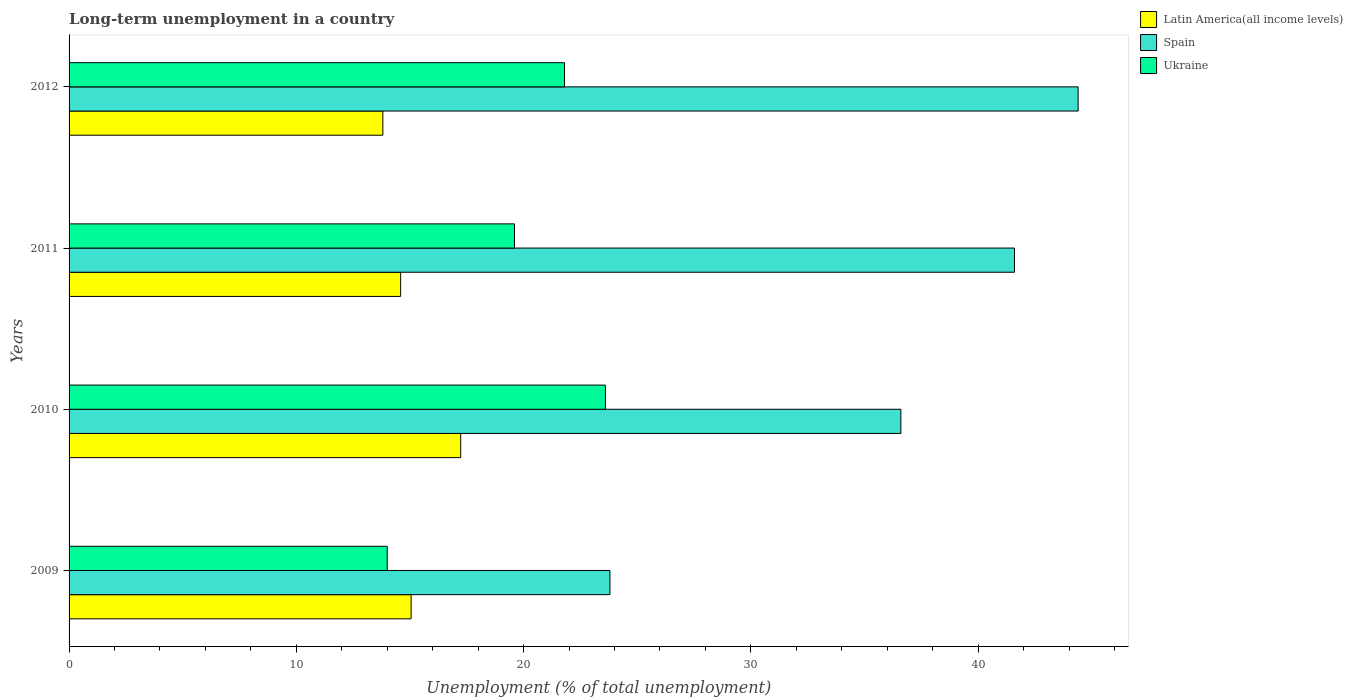How many different coloured bars are there?
Keep it short and to the point. 3. How many groups of bars are there?
Give a very brief answer. 4. Are the number of bars per tick equal to the number of legend labels?
Provide a succinct answer. Yes. Are the number of bars on each tick of the Y-axis equal?
Ensure brevity in your answer.  Yes. How many bars are there on the 3rd tick from the bottom?
Offer a very short reply. 3. What is the label of the 4th group of bars from the top?
Give a very brief answer. 2009. In how many cases, is the number of bars for a given year not equal to the number of legend labels?
Your response must be concise. 0. What is the percentage of long-term unemployed population in Ukraine in 2010?
Offer a very short reply. 23.6. Across all years, what is the maximum percentage of long-term unemployed population in Spain?
Ensure brevity in your answer.  44.4. Across all years, what is the minimum percentage of long-term unemployed population in Ukraine?
Provide a succinct answer. 14. In which year was the percentage of long-term unemployed population in Spain maximum?
Ensure brevity in your answer.  2012. What is the total percentage of long-term unemployed population in Latin America(all income levels) in the graph?
Offer a very short reply. 60.68. What is the difference between the percentage of long-term unemployed population in Latin America(all income levels) in 2009 and that in 2010?
Your response must be concise. -2.18. What is the difference between the percentage of long-term unemployed population in Ukraine in 2009 and the percentage of long-term unemployed population in Spain in 2012?
Provide a short and direct response. -30.4. What is the average percentage of long-term unemployed population in Latin America(all income levels) per year?
Provide a short and direct response. 15.17. In the year 2010, what is the difference between the percentage of long-term unemployed population in Ukraine and percentage of long-term unemployed population in Latin America(all income levels)?
Offer a very short reply. 6.37. What is the ratio of the percentage of long-term unemployed population in Ukraine in 2009 to that in 2010?
Offer a very short reply. 0.59. Is the percentage of long-term unemployed population in Latin America(all income levels) in 2009 less than that in 2012?
Provide a short and direct response. No. Is the difference between the percentage of long-term unemployed population in Ukraine in 2009 and 2010 greater than the difference between the percentage of long-term unemployed population in Latin America(all income levels) in 2009 and 2010?
Your answer should be very brief. No. What is the difference between the highest and the second highest percentage of long-term unemployed population in Spain?
Your response must be concise. 2.8. What is the difference between the highest and the lowest percentage of long-term unemployed population in Ukraine?
Your answer should be compact. 9.6. In how many years, is the percentage of long-term unemployed population in Ukraine greater than the average percentage of long-term unemployed population in Ukraine taken over all years?
Ensure brevity in your answer.  2. What does the 3rd bar from the bottom in 2009 represents?
Your response must be concise. Ukraine. Are all the bars in the graph horizontal?
Provide a succinct answer. Yes. How are the legend labels stacked?
Your response must be concise. Vertical. What is the title of the graph?
Make the answer very short. Long-term unemployment in a country. Does "Samoa" appear as one of the legend labels in the graph?
Provide a succinct answer. No. What is the label or title of the X-axis?
Keep it short and to the point. Unemployment (% of total unemployment). What is the label or title of the Y-axis?
Provide a succinct answer. Years. What is the Unemployment (% of total unemployment) in Latin America(all income levels) in 2009?
Offer a terse response. 15.05. What is the Unemployment (% of total unemployment) of Spain in 2009?
Provide a short and direct response. 23.8. What is the Unemployment (% of total unemployment) in Latin America(all income levels) in 2010?
Offer a terse response. 17.23. What is the Unemployment (% of total unemployment) in Spain in 2010?
Offer a very short reply. 36.6. What is the Unemployment (% of total unemployment) in Ukraine in 2010?
Give a very brief answer. 23.6. What is the Unemployment (% of total unemployment) in Latin America(all income levels) in 2011?
Give a very brief answer. 14.59. What is the Unemployment (% of total unemployment) of Spain in 2011?
Your response must be concise. 41.6. What is the Unemployment (% of total unemployment) of Ukraine in 2011?
Provide a short and direct response. 19.6. What is the Unemployment (% of total unemployment) of Latin America(all income levels) in 2012?
Ensure brevity in your answer.  13.81. What is the Unemployment (% of total unemployment) in Spain in 2012?
Offer a very short reply. 44.4. What is the Unemployment (% of total unemployment) in Ukraine in 2012?
Your answer should be compact. 21.8. Across all years, what is the maximum Unemployment (% of total unemployment) in Latin America(all income levels)?
Your answer should be very brief. 17.23. Across all years, what is the maximum Unemployment (% of total unemployment) of Spain?
Ensure brevity in your answer.  44.4. Across all years, what is the maximum Unemployment (% of total unemployment) in Ukraine?
Your response must be concise. 23.6. Across all years, what is the minimum Unemployment (% of total unemployment) in Latin America(all income levels)?
Your answer should be compact. 13.81. Across all years, what is the minimum Unemployment (% of total unemployment) in Spain?
Your response must be concise. 23.8. What is the total Unemployment (% of total unemployment) of Latin America(all income levels) in the graph?
Provide a short and direct response. 60.68. What is the total Unemployment (% of total unemployment) in Spain in the graph?
Give a very brief answer. 146.4. What is the total Unemployment (% of total unemployment) of Ukraine in the graph?
Ensure brevity in your answer.  79. What is the difference between the Unemployment (% of total unemployment) in Latin America(all income levels) in 2009 and that in 2010?
Offer a terse response. -2.18. What is the difference between the Unemployment (% of total unemployment) of Spain in 2009 and that in 2010?
Provide a short and direct response. -12.8. What is the difference between the Unemployment (% of total unemployment) of Latin America(all income levels) in 2009 and that in 2011?
Provide a succinct answer. 0.46. What is the difference between the Unemployment (% of total unemployment) of Spain in 2009 and that in 2011?
Provide a short and direct response. -17.8. What is the difference between the Unemployment (% of total unemployment) in Ukraine in 2009 and that in 2011?
Make the answer very short. -5.6. What is the difference between the Unemployment (% of total unemployment) of Latin America(all income levels) in 2009 and that in 2012?
Your response must be concise. 1.24. What is the difference between the Unemployment (% of total unemployment) in Spain in 2009 and that in 2012?
Provide a succinct answer. -20.6. What is the difference between the Unemployment (% of total unemployment) of Latin America(all income levels) in 2010 and that in 2011?
Offer a very short reply. 2.64. What is the difference between the Unemployment (% of total unemployment) in Ukraine in 2010 and that in 2011?
Provide a succinct answer. 4. What is the difference between the Unemployment (% of total unemployment) in Latin America(all income levels) in 2010 and that in 2012?
Offer a very short reply. 3.43. What is the difference between the Unemployment (% of total unemployment) of Latin America(all income levels) in 2011 and that in 2012?
Your response must be concise. 0.78. What is the difference between the Unemployment (% of total unemployment) of Spain in 2011 and that in 2012?
Give a very brief answer. -2.8. What is the difference between the Unemployment (% of total unemployment) of Ukraine in 2011 and that in 2012?
Offer a terse response. -2.2. What is the difference between the Unemployment (% of total unemployment) of Latin America(all income levels) in 2009 and the Unemployment (% of total unemployment) of Spain in 2010?
Your answer should be very brief. -21.55. What is the difference between the Unemployment (% of total unemployment) of Latin America(all income levels) in 2009 and the Unemployment (% of total unemployment) of Ukraine in 2010?
Your answer should be compact. -8.55. What is the difference between the Unemployment (% of total unemployment) of Latin America(all income levels) in 2009 and the Unemployment (% of total unemployment) of Spain in 2011?
Your answer should be very brief. -26.55. What is the difference between the Unemployment (% of total unemployment) in Latin America(all income levels) in 2009 and the Unemployment (% of total unemployment) in Ukraine in 2011?
Offer a terse response. -4.55. What is the difference between the Unemployment (% of total unemployment) in Spain in 2009 and the Unemployment (% of total unemployment) in Ukraine in 2011?
Make the answer very short. 4.2. What is the difference between the Unemployment (% of total unemployment) in Latin America(all income levels) in 2009 and the Unemployment (% of total unemployment) in Spain in 2012?
Ensure brevity in your answer.  -29.35. What is the difference between the Unemployment (% of total unemployment) in Latin America(all income levels) in 2009 and the Unemployment (% of total unemployment) in Ukraine in 2012?
Keep it short and to the point. -6.75. What is the difference between the Unemployment (% of total unemployment) of Latin America(all income levels) in 2010 and the Unemployment (% of total unemployment) of Spain in 2011?
Your answer should be very brief. -24.37. What is the difference between the Unemployment (% of total unemployment) in Latin America(all income levels) in 2010 and the Unemployment (% of total unemployment) in Ukraine in 2011?
Provide a succinct answer. -2.37. What is the difference between the Unemployment (% of total unemployment) in Spain in 2010 and the Unemployment (% of total unemployment) in Ukraine in 2011?
Offer a very short reply. 17. What is the difference between the Unemployment (% of total unemployment) of Latin America(all income levels) in 2010 and the Unemployment (% of total unemployment) of Spain in 2012?
Your answer should be very brief. -27.17. What is the difference between the Unemployment (% of total unemployment) in Latin America(all income levels) in 2010 and the Unemployment (% of total unemployment) in Ukraine in 2012?
Offer a terse response. -4.57. What is the difference between the Unemployment (% of total unemployment) of Spain in 2010 and the Unemployment (% of total unemployment) of Ukraine in 2012?
Keep it short and to the point. 14.8. What is the difference between the Unemployment (% of total unemployment) of Latin America(all income levels) in 2011 and the Unemployment (% of total unemployment) of Spain in 2012?
Provide a short and direct response. -29.81. What is the difference between the Unemployment (% of total unemployment) in Latin America(all income levels) in 2011 and the Unemployment (% of total unemployment) in Ukraine in 2012?
Your answer should be very brief. -7.21. What is the difference between the Unemployment (% of total unemployment) of Spain in 2011 and the Unemployment (% of total unemployment) of Ukraine in 2012?
Offer a terse response. 19.8. What is the average Unemployment (% of total unemployment) in Latin America(all income levels) per year?
Keep it short and to the point. 15.17. What is the average Unemployment (% of total unemployment) of Spain per year?
Ensure brevity in your answer.  36.6. What is the average Unemployment (% of total unemployment) in Ukraine per year?
Your answer should be very brief. 19.75. In the year 2009, what is the difference between the Unemployment (% of total unemployment) of Latin America(all income levels) and Unemployment (% of total unemployment) of Spain?
Provide a succinct answer. -8.75. In the year 2009, what is the difference between the Unemployment (% of total unemployment) of Latin America(all income levels) and Unemployment (% of total unemployment) of Ukraine?
Provide a short and direct response. 1.05. In the year 2010, what is the difference between the Unemployment (% of total unemployment) in Latin America(all income levels) and Unemployment (% of total unemployment) in Spain?
Offer a very short reply. -19.37. In the year 2010, what is the difference between the Unemployment (% of total unemployment) of Latin America(all income levels) and Unemployment (% of total unemployment) of Ukraine?
Offer a terse response. -6.37. In the year 2010, what is the difference between the Unemployment (% of total unemployment) of Spain and Unemployment (% of total unemployment) of Ukraine?
Provide a succinct answer. 13. In the year 2011, what is the difference between the Unemployment (% of total unemployment) of Latin America(all income levels) and Unemployment (% of total unemployment) of Spain?
Offer a terse response. -27.01. In the year 2011, what is the difference between the Unemployment (% of total unemployment) in Latin America(all income levels) and Unemployment (% of total unemployment) in Ukraine?
Your response must be concise. -5.01. In the year 2011, what is the difference between the Unemployment (% of total unemployment) of Spain and Unemployment (% of total unemployment) of Ukraine?
Ensure brevity in your answer.  22. In the year 2012, what is the difference between the Unemployment (% of total unemployment) of Latin America(all income levels) and Unemployment (% of total unemployment) of Spain?
Provide a short and direct response. -30.59. In the year 2012, what is the difference between the Unemployment (% of total unemployment) in Latin America(all income levels) and Unemployment (% of total unemployment) in Ukraine?
Ensure brevity in your answer.  -7.99. In the year 2012, what is the difference between the Unemployment (% of total unemployment) of Spain and Unemployment (% of total unemployment) of Ukraine?
Your answer should be very brief. 22.6. What is the ratio of the Unemployment (% of total unemployment) in Latin America(all income levels) in 2009 to that in 2010?
Give a very brief answer. 0.87. What is the ratio of the Unemployment (% of total unemployment) in Spain in 2009 to that in 2010?
Provide a succinct answer. 0.65. What is the ratio of the Unemployment (% of total unemployment) of Ukraine in 2009 to that in 2010?
Keep it short and to the point. 0.59. What is the ratio of the Unemployment (% of total unemployment) in Latin America(all income levels) in 2009 to that in 2011?
Offer a terse response. 1.03. What is the ratio of the Unemployment (% of total unemployment) in Spain in 2009 to that in 2011?
Keep it short and to the point. 0.57. What is the ratio of the Unemployment (% of total unemployment) in Latin America(all income levels) in 2009 to that in 2012?
Your response must be concise. 1.09. What is the ratio of the Unemployment (% of total unemployment) in Spain in 2009 to that in 2012?
Offer a very short reply. 0.54. What is the ratio of the Unemployment (% of total unemployment) of Ukraine in 2009 to that in 2012?
Your answer should be compact. 0.64. What is the ratio of the Unemployment (% of total unemployment) in Latin America(all income levels) in 2010 to that in 2011?
Provide a succinct answer. 1.18. What is the ratio of the Unemployment (% of total unemployment) in Spain in 2010 to that in 2011?
Make the answer very short. 0.88. What is the ratio of the Unemployment (% of total unemployment) of Ukraine in 2010 to that in 2011?
Make the answer very short. 1.2. What is the ratio of the Unemployment (% of total unemployment) of Latin America(all income levels) in 2010 to that in 2012?
Your answer should be compact. 1.25. What is the ratio of the Unemployment (% of total unemployment) of Spain in 2010 to that in 2012?
Offer a terse response. 0.82. What is the ratio of the Unemployment (% of total unemployment) in Ukraine in 2010 to that in 2012?
Make the answer very short. 1.08. What is the ratio of the Unemployment (% of total unemployment) in Latin America(all income levels) in 2011 to that in 2012?
Make the answer very short. 1.06. What is the ratio of the Unemployment (% of total unemployment) in Spain in 2011 to that in 2012?
Your answer should be compact. 0.94. What is the ratio of the Unemployment (% of total unemployment) of Ukraine in 2011 to that in 2012?
Keep it short and to the point. 0.9. What is the difference between the highest and the second highest Unemployment (% of total unemployment) of Latin America(all income levels)?
Give a very brief answer. 2.18. What is the difference between the highest and the lowest Unemployment (% of total unemployment) in Latin America(all income levels)?
Provide a short and direct response. 3.43. What is the difference between the highest and the lowest Unemployment (% of total unemployment) of Spain?
Ensure brevity in your answer.  20.6. What is the difference between the highest and the lowest Unemployment (% of total unemployment) in Ukraine?
Provide a succinct answer. 9.6. 